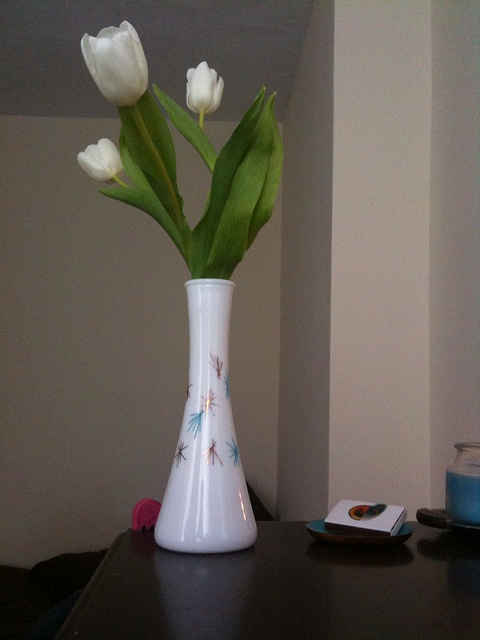<image>What do the flowers smell like? It is unknown what the flowers smell like. What do the flowers smell like? I don't know how the flowers smell like. But it can be both pretty and sweet. 